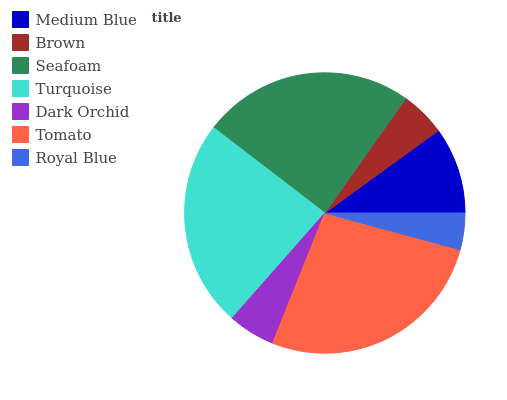Is Royal Blue the minimum?
Answer yes or no. Yes. Is Tomato the maximum?
Answer yes or no. Yes. Is Brown the minimum?
Answer yes or no. No. Is Brown the maximum?
Answer yes or no. No. Is Medium Blue greater than Brown?
Answer yes or no. Yes. Is Brown less than Medium Blue?
Answer yes or no. Yes. Is Brown greater than Medium Blue?
Answer yes or no. No. Is Medium Blue less than Brown?
Answer yes or no. No. Is Medium Blue the high median?
Answer yes or no. Yes. Is Medium Blue the low median?
Answer yes or no. Yes. Is Turquoise the high median?
Answer yes or no. No. Is Dark Orchid the low median?
Answer yes or no. No. 